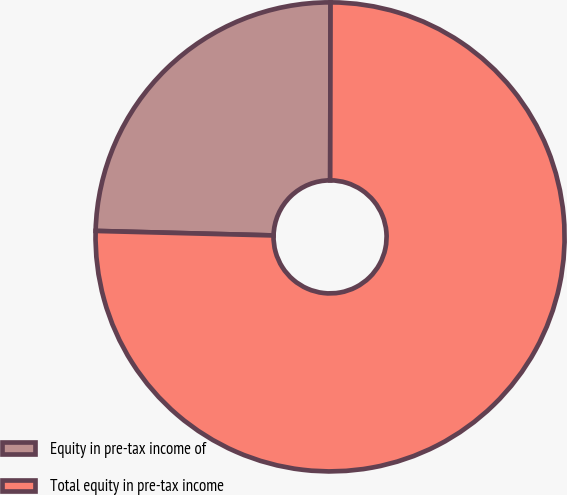<chart> <loc_0><loc_0><loc_500><loc_500><pie_chart><fcel>Equity in pre-tax income of<fcel>Total equity in pre-tax income<nl><fcel>24.63%<fcel>75.37%<nl></chart> 